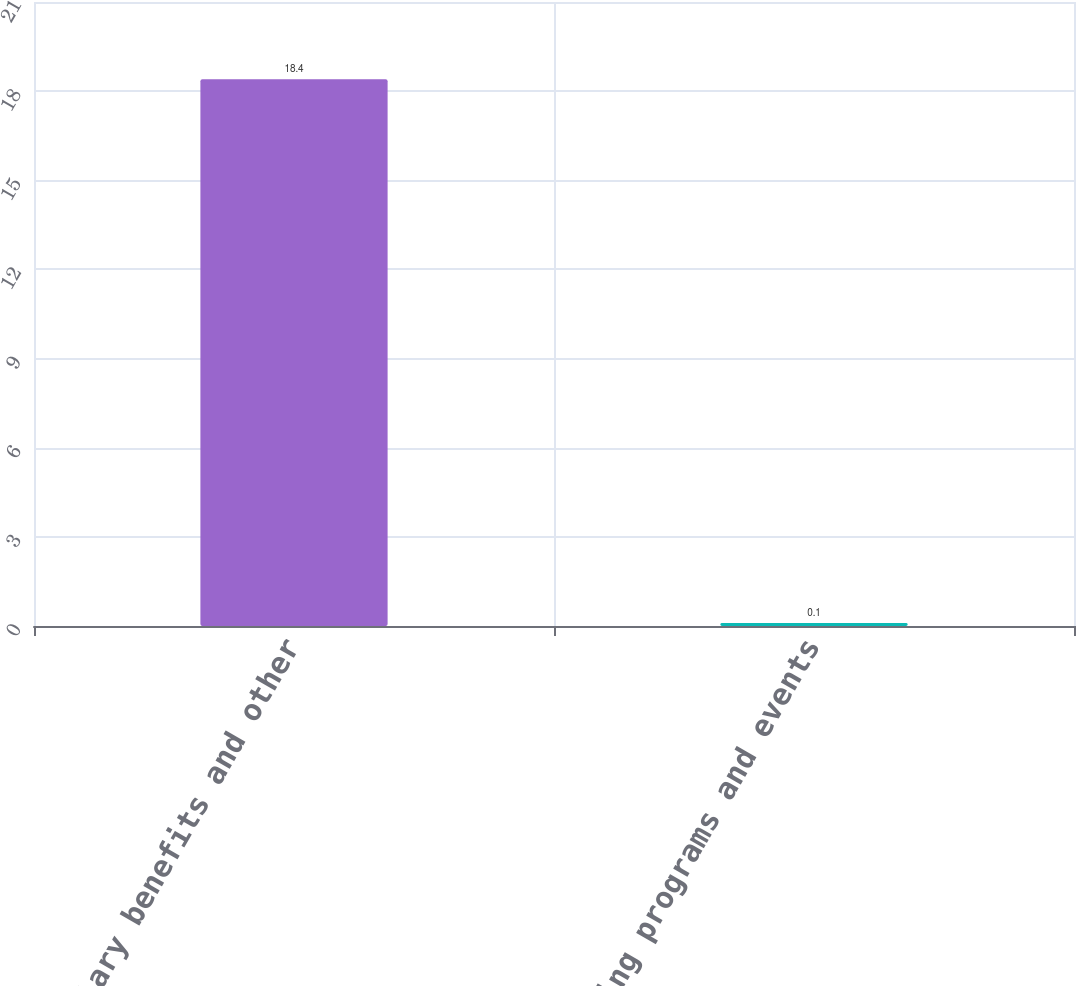Convert chart. <chart><loc_0><loc_0><loc_500><loc_500><bar_chart><fcel>Salary benefits and other<fcel>Marketing programs and events<nl><fcel>18.4<fcel>0.1<nl></chart> 